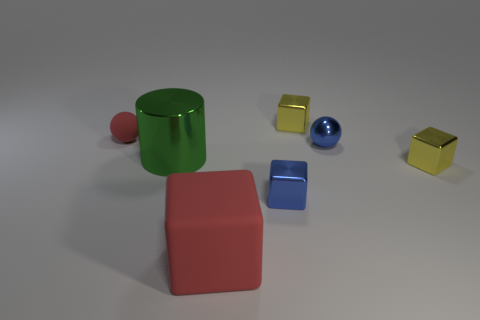Add 2 cubes. How many objects exist? 9 Subtract all large red blocks. How many blocks are left? 3 Subtract all blocks. How many objects are left? 3 Subtract all gray balls. How many yellow blocks are left? 2 Subtract 3 blocks. How many blocks are left? 1 Add 5 cylinders. How many cylinders are left? 6 Add 6 large red matte objects. How many large red matte objects exist? 7 Subtract all yellow blocks. How many blocks are left? 2 Subtract 0 gray cylinders. How many objects are left? 7 Subtract all cyan balls. Subtract all red cylinders. How many balls are left? 2 